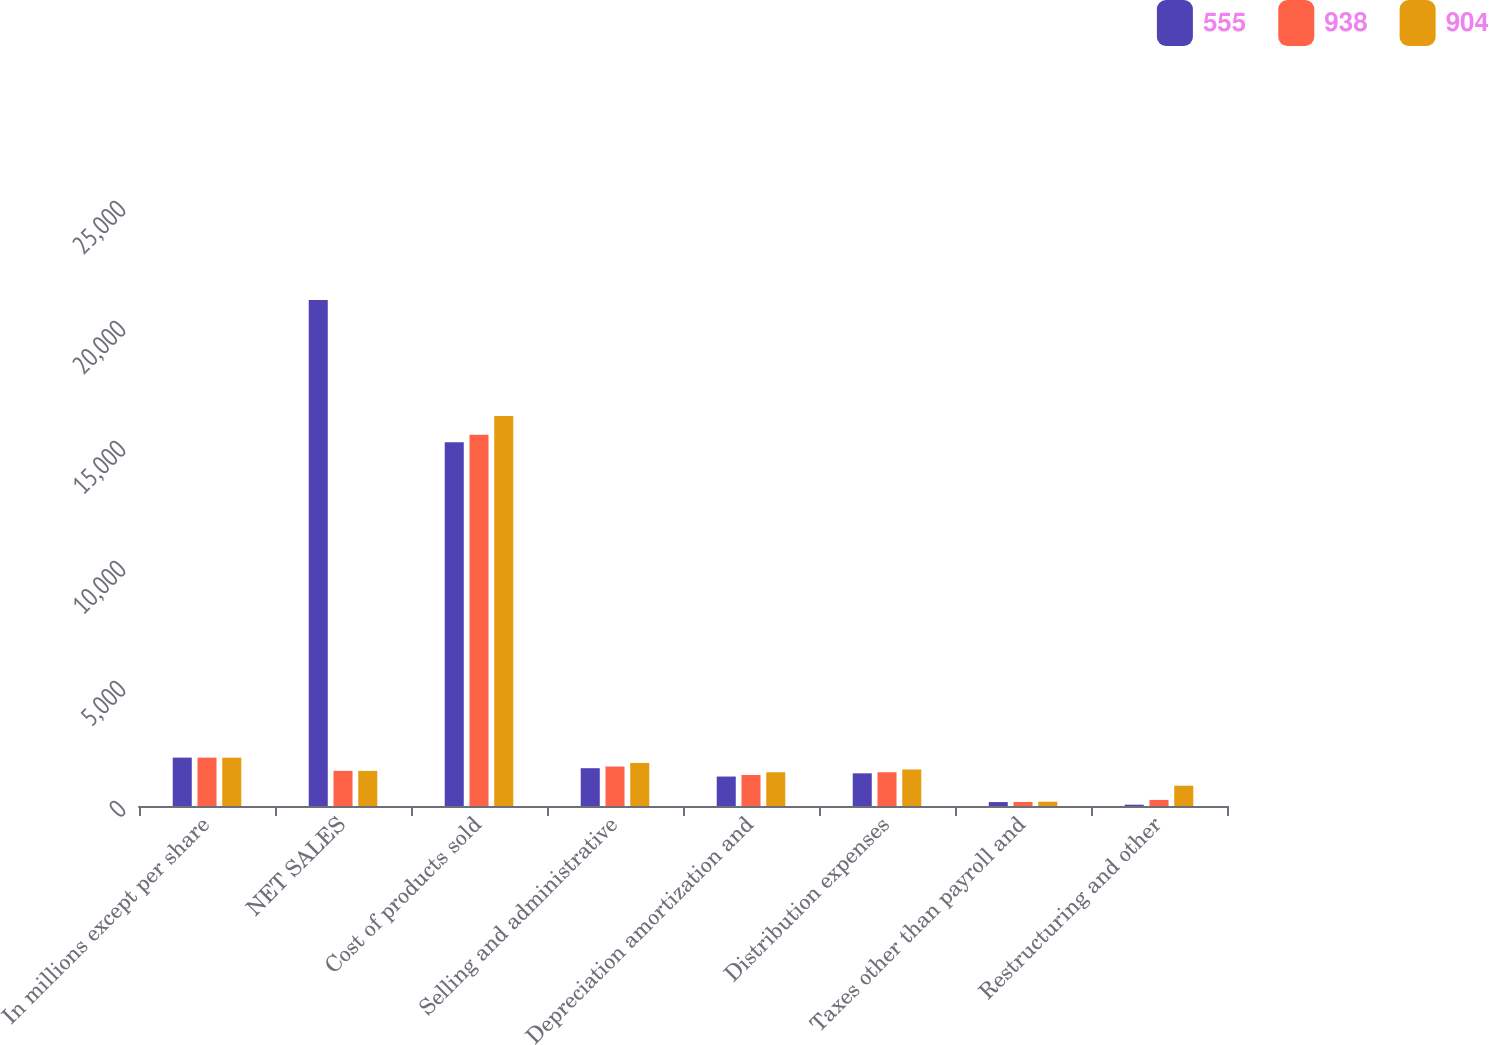Convert chart. <chart><loc_0><loc_0><loc_500><loc_500><stacked_bar_chart><ecel><fcel>In millions except per share<fcel>NET SALES<fcel>Cost of products sold<fcel>Selling and administrative<fcel>Depreciation amortization and<fcel>Distribution expenses<fcel>Taxes other than payroll and<fcel>Restructuring and other<nl><fcel>555<fcel>2016<fcel>21079<fcel>15152<fcel>1575<fcel>1227<fcel>1361<fcel>164<fcel>54<nl><fcel>938<fcel>2015<fcel>1463.5<fcel>15468<fcel>1645<fcel>1294<fcel>1406<fcel>168<fcel>252<nl><fcel>904<fcel>2014<fcel>1463.5<fcel>16254<fcel>1793<fcel>1406<fcel>1521<fcel>180<fcel>846<nl></chart> 